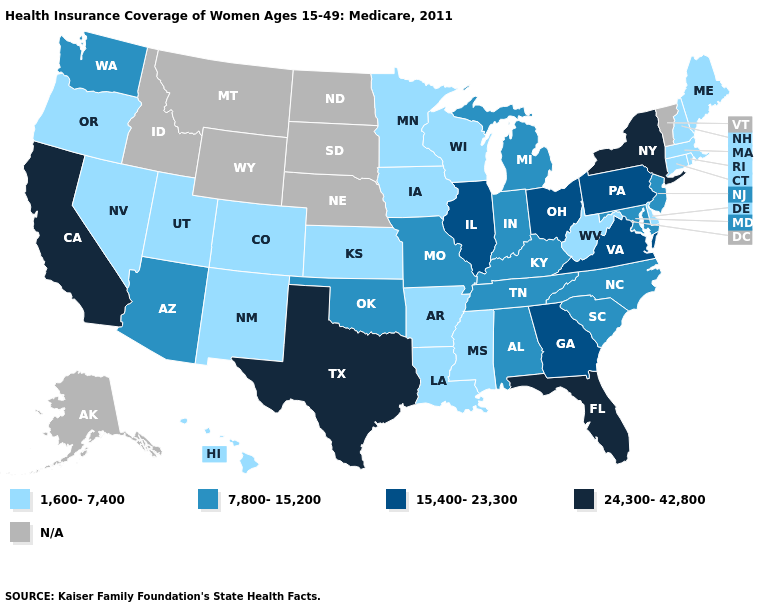What is the highest value in states that border Illinois?
Answer briefly. 7,800-15,200. Among the states that border Oregon , does Nevada have the lowest value?
Quick response, please. Yes. Name the states that have a value in the range 1,600-7,400?
Give a very brief answer. Arkansas, Colorado, Connecticut, Delaware, Hawaii, Iowa, Kansas, Louisiana, Maine, Massachusetts, Minnesota, Mississippi, Nevada, New Hampshire, New Mexico, Oregon, Rhode Island, Utah, West Virginia, Wisconsin. Name the states that have a value in the range 1,600-7,400?
Answer briefly. Arkansas, Colorado, Connecticut, Delaware, Hawaii, Iowa, Kansas, Louisiana, Maine, Massachusetts, Minnesota, Mississippi, Nevada, New Hampshire, New Mexico, Oregon, Rhode Island, Utah, West Virginia, Wisconsin. Name the states that have a value in the range 24,300-42,800?
Keep it brief. California, Florida, New York, Texas. Does Arkansas have the lowest value in the USA?
Answer briefly. Yes. Does Minnesota have the lowest value in the MidWest?
Be succinct. Yes. What is the value of Hawaii?
Concise answer only. 1,600-7,400. What is the highest value in the USA?
Concise answer only. 24,300-42,800. What is the value of Kentucky?
Answer briefly. 7,800-15,200. What is the value of Colorado?
Keep it brief. 1,600-7,400. Is the legend a continuous bar?
Quick response, please. No. What is the lowest value in states that border Delaware?
Write a very short answer. 7,800-15,200. What is the lowest value in states that border Arizona?
Answer briefly. 1,600-7,400. What is the value of North Dakota?
Give a very brief answer. N/A. 